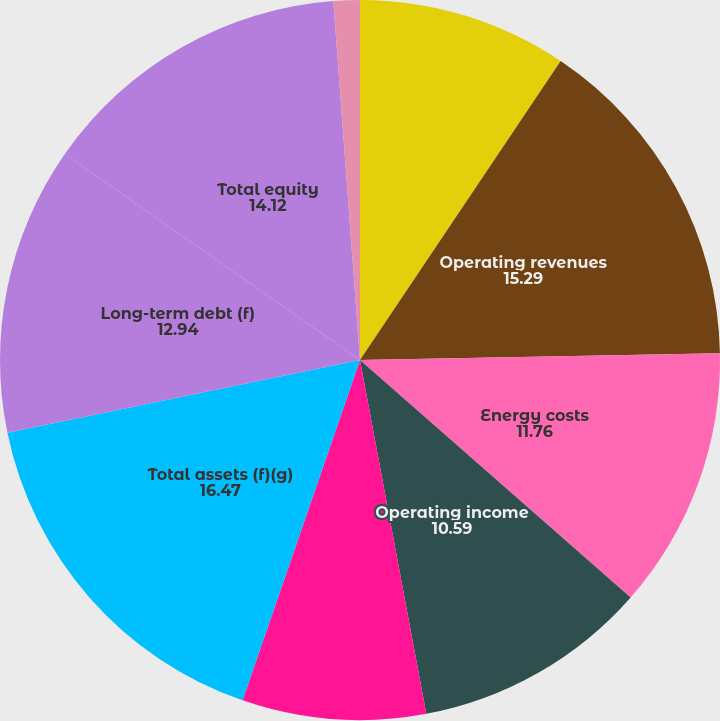Convert chart. <chart><loc_0><loc_0><loc_500><loc_500><pie_chart><fcel>(Millions of Dollars except<fcel>Operating revenues<fcel>Energy costs<fcel>Operating income<fcel>Net income<fcel>Total assets (f)(g)<fcel>Long-term debt (f)<fcel>Total equity<fcel>Net Income per common share -<nl><fcel>9.41%<fcel>15.29%<fcel>11.76%<fcel>10.59%<fcel>8.24%<fcel>16.47%<fcel>12.94%<fcel>14.12%<fcel>1.18%<nl></chart> 